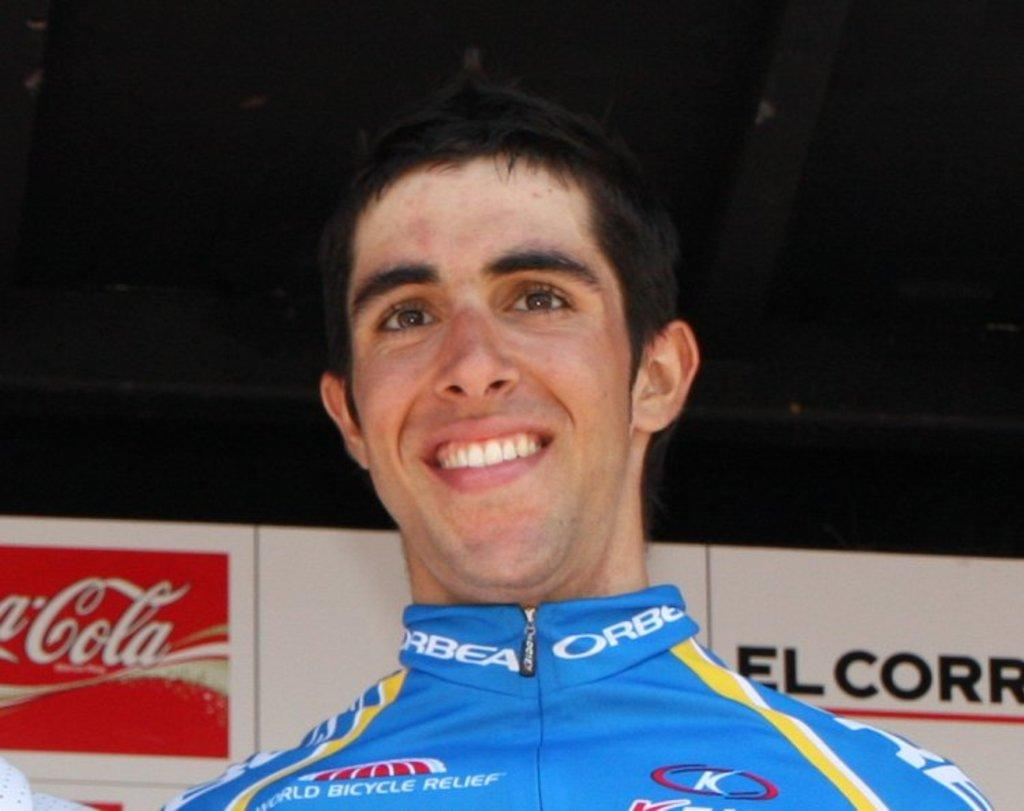Provide a one-sentence caption for the provided image. A man wearing a racing uniform is smiling in front of a Coca-Cola sign. 